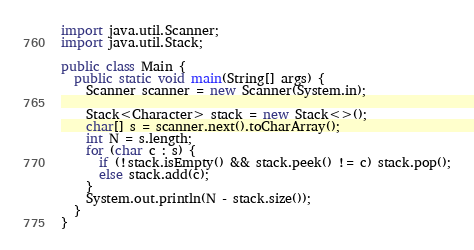<code> <loc_0><loc_0><loc_500><loc_500><_Java_>import java.util.Scanner;
import java.util.Stack;

public class Main {
  public static void main(String[] args) {
    Scanner scanner = new Scanner(System.in);

    Stack<Character> stack = new Stack<>();
    char[] s = scanner.next().toCharArray();
    int N = s.length;
    for (char c : s) {
      if (!stack.isEmpty() && stack.peek() != c) stack.pop();
      else stack.add(c);
    }
    System.out.println(N - stack.size());
  }
}
</code> 